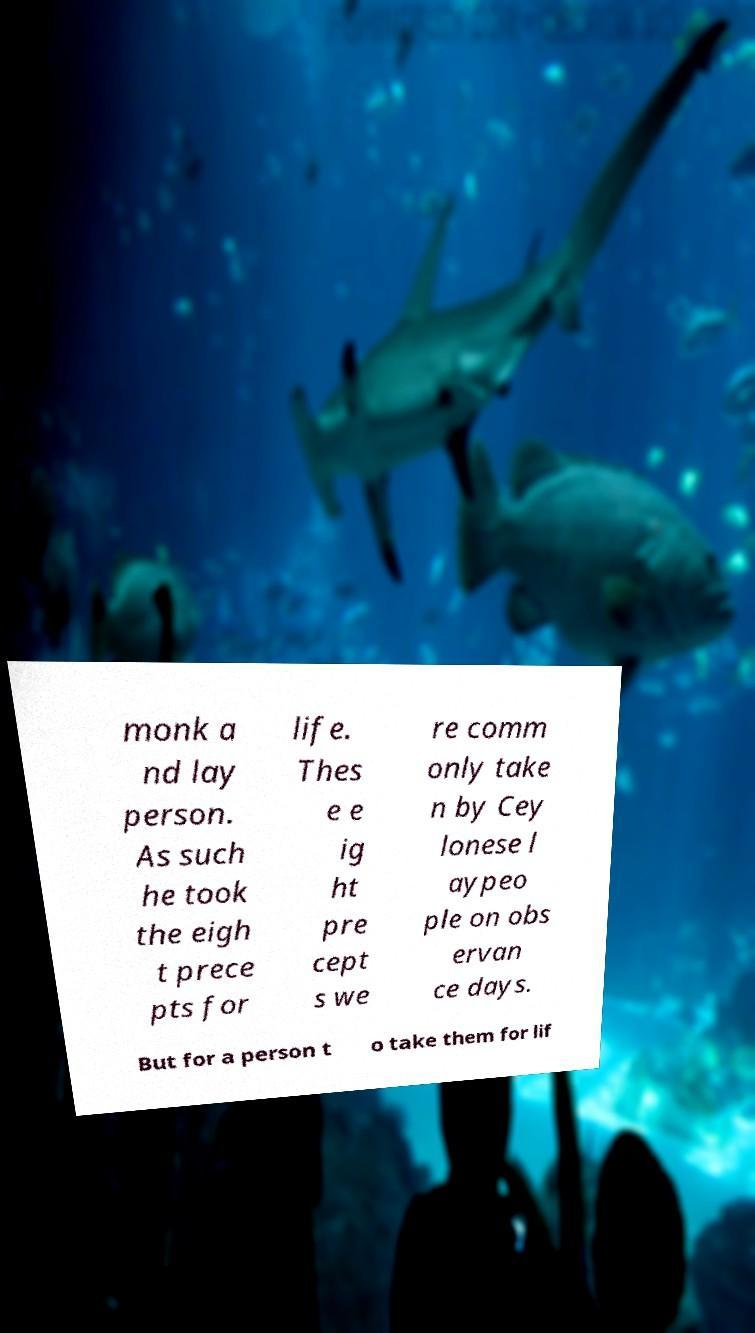Could you assist in decoding the text presented in this image and type it out clearly? monk a nd lay person. As such he took the eigh t prece pts for life. Thes e e ig ht pre cept s we re comm only take n by Cey lonese l aypeo ple on obs ervan ce days. But for a person t o take them for lif 